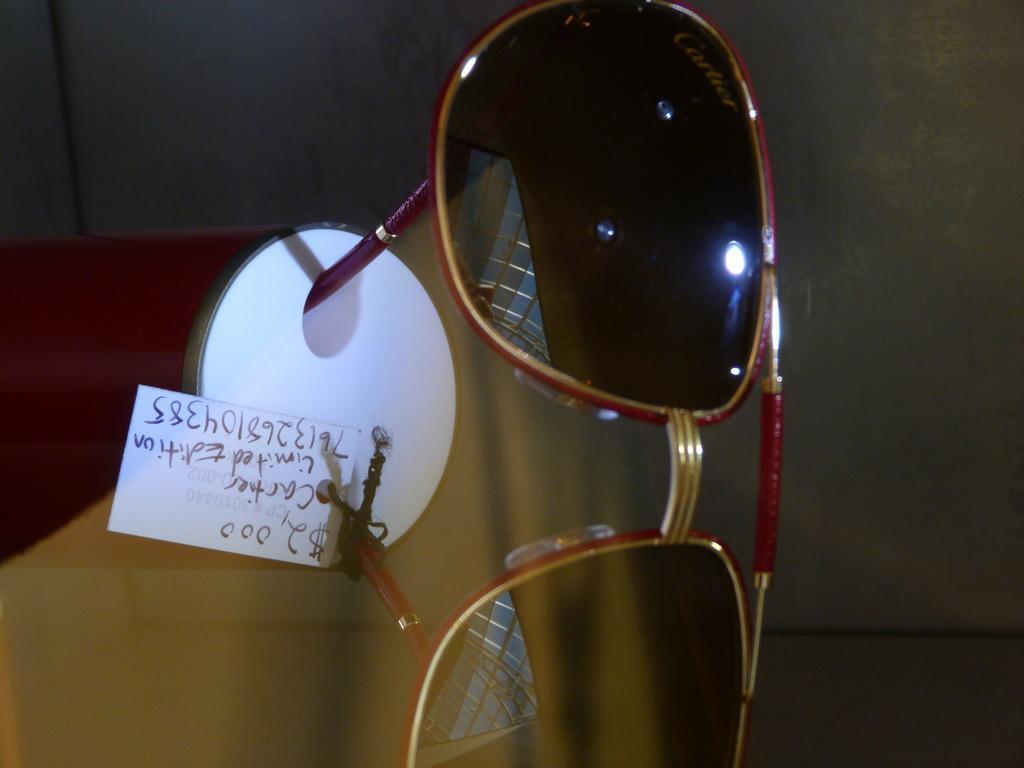How would you summarize this image in a sentence or two? In this image I can see goggles which are black, maroon and gold in color. I can see they are attached to the white colored object and a white colored paper with few words written on it. I can see the blurry background. 